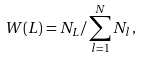Convert formula to latex. <formula><loc_0><loc_0><loc_500><loc_500>W ( L ) = N _ { L } / \sum _ { l = 1 } ^ { N } N _ { l } \, ,</formula> 